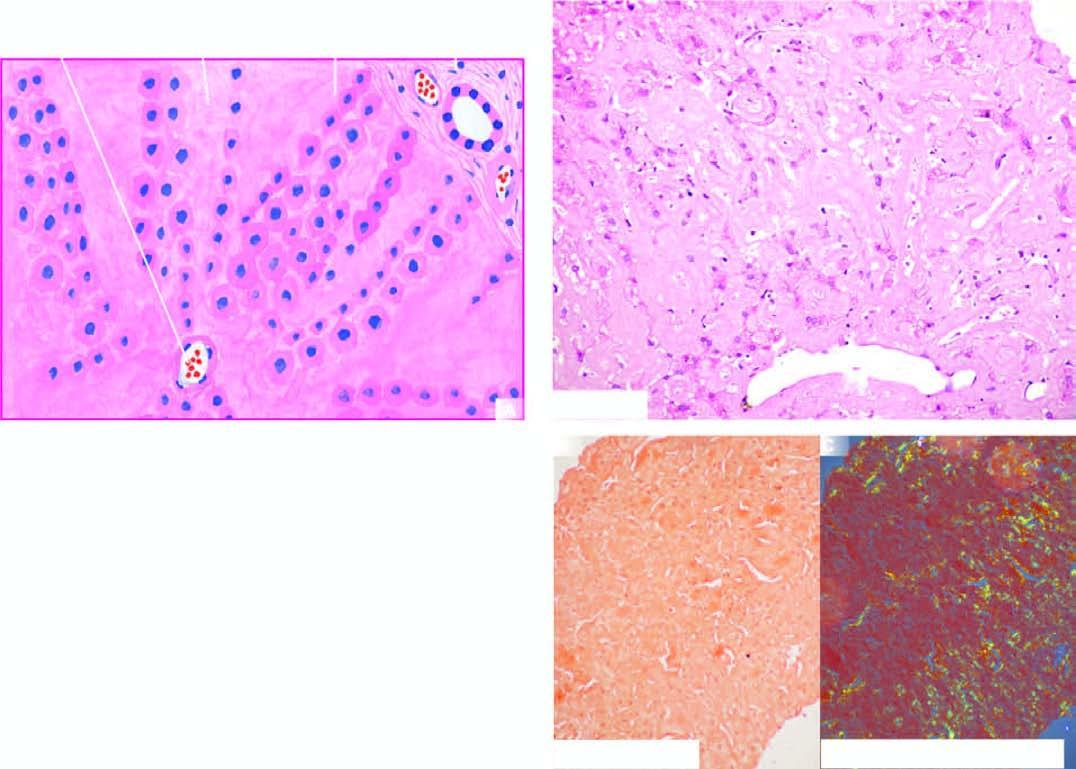what shows apple-green birefringence?
Answer the question using a single word or phrase. The figure 